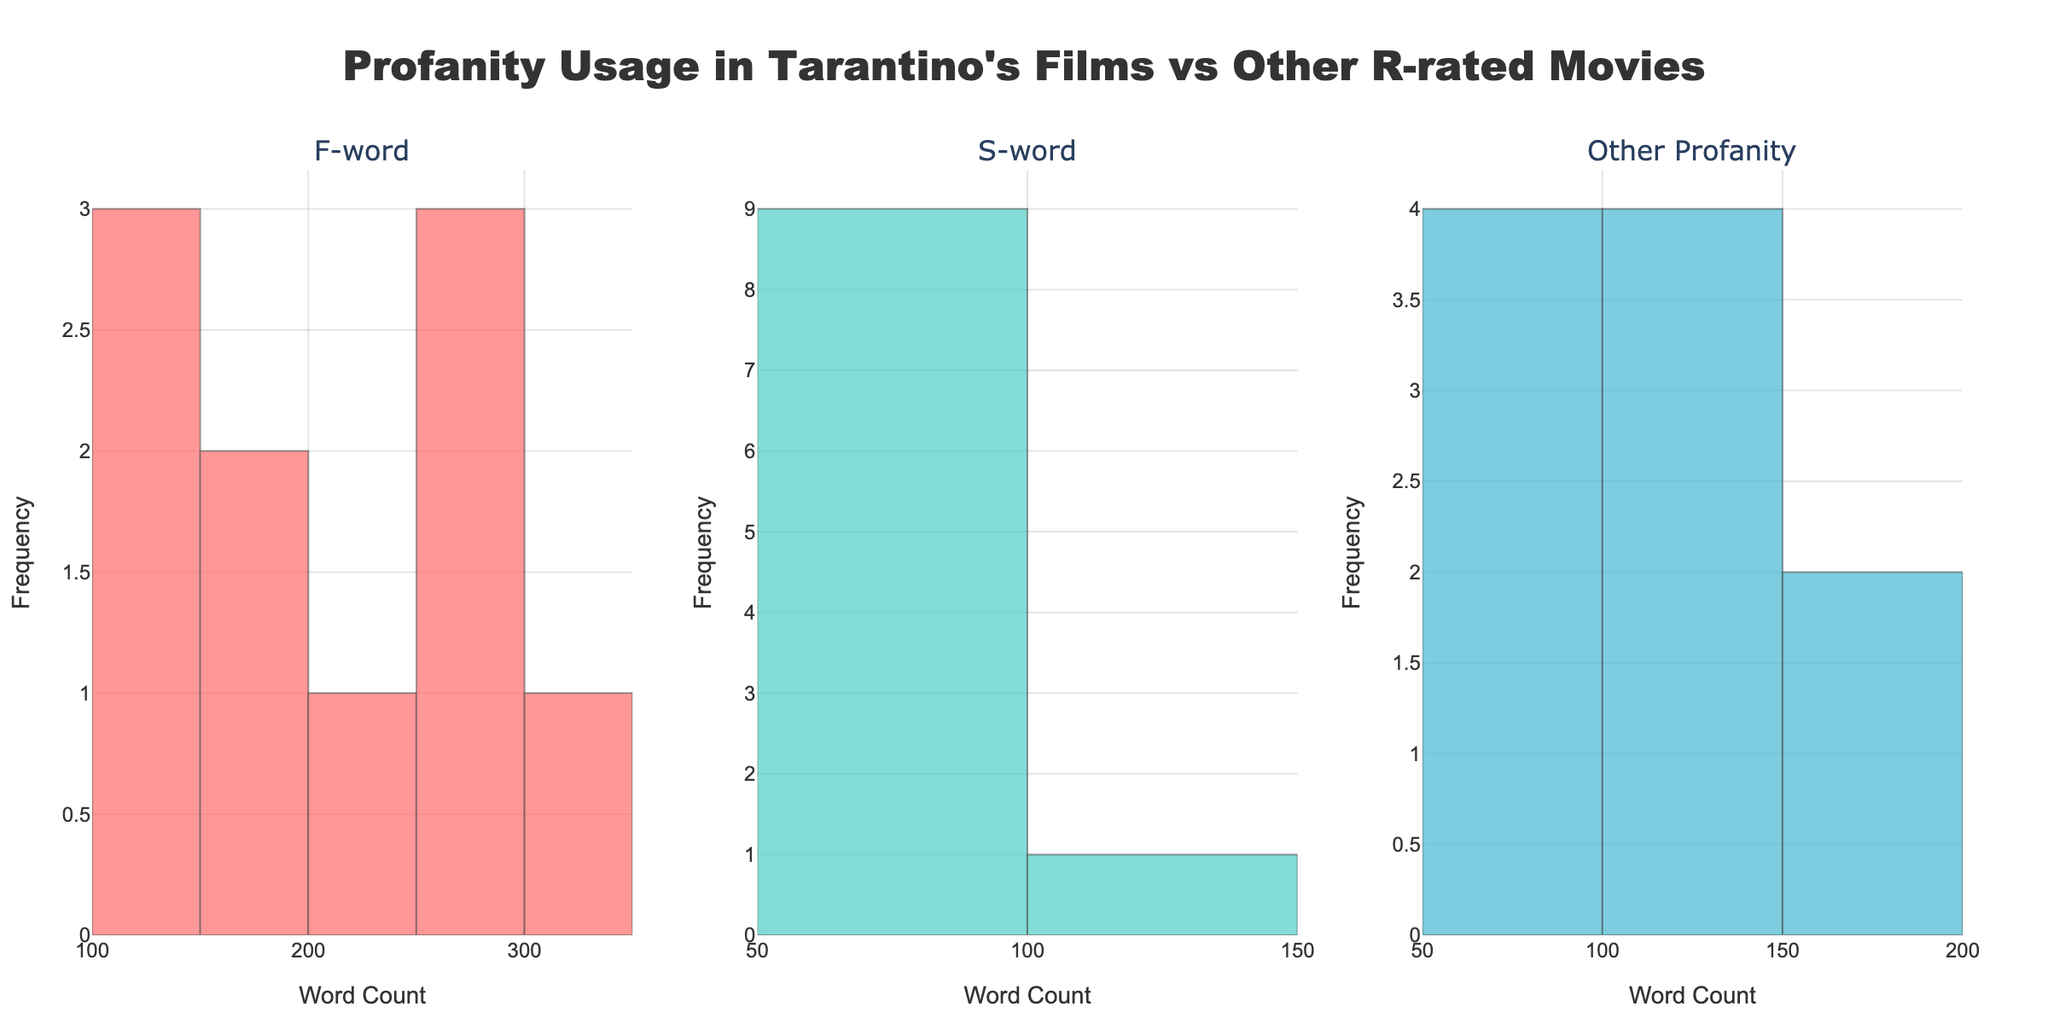What's the title of the figure? The title is usually placed at the top of the figure and is styled prominently. The title of this plot is "Profanity Usage in Tarantino's Films vs Other R-rated Movies."
Answer: Profanity Usage in Tarantino's Films vs Other R-rated Movies Which type of profanity has the greatest overall occurrence in the dataset? By visually inspecting the histograms, we can determine which bar is consistently the highest. The 'F-word' histogram has the most elevated bars compared to 'S-word' and 'Other Profanity.'
Answer: F-word What is the highest range of occurrences for 'S-word' in the films? From the histogram, we see that the highest range that appears in the 'S-word' plot is between 50-100 occurrences.
Answer: 50-100 Compare the number of times 'F-word' and 'S-word' occurred most frequently. Which is higher? To answer this, observe which histogram has higher bars for the most frequent range. The 'F-word' histogram consistently has higher bars compared to the 'S-word' histogram.
Answer: F-word Are Quentin Tarantino's films outliers in any of the profanity categories compared to other R-rated films? To determine this, we evaluate whether any of Tarantino's film data points are in the extreme ranges of the histograms. In the 'F-word' and 'Other Profanity' histograms, Tarantino's films such as 'Pulp Fiction' and 'Reservoir Dogs' are indeed outliers.
Answer: Yes What is the frequency range of the 'Other Profanity' that appears most often in the dataset? Looking at the histogram for 'Other Profanity,' the highest bar represents the range 100-150.
Answer: 100-150 Which film contains the highest number of 'F-word' occurrences? From visually inspecting the histogram for the 'F-word', the highest data point is from 'Reservoir Dogs' with 269 counts.
Answer: Reservoir Dogs 